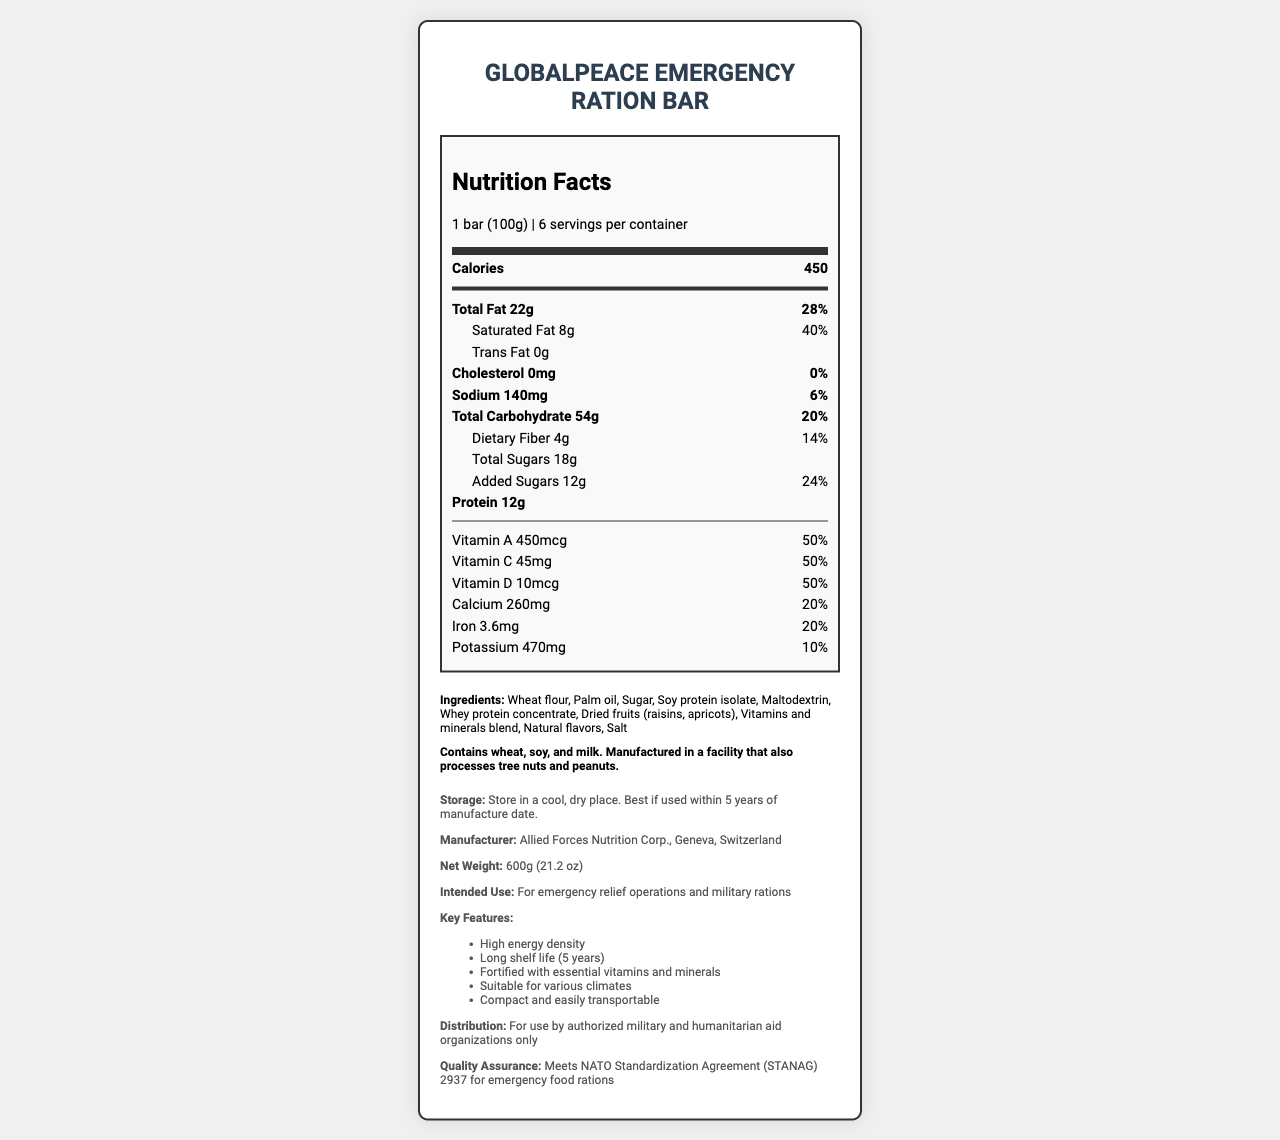who is the manufacturer of the GlobalPeace Emergency Ration Bar? The document explicitly states that the manufacturer is Allied Forces Nutrition Corp., Geneva, Switzerland.
Answer: Allied Forces Nutrition Corp., Geneva, Switzerland what is the serving size of one bar? The document states that the serving size is 1 bar (100g).
Answer: 1 bar (100g) how many calories are in one serving of the emergency ration bar? The document clearly lists the calorie content as 450 per serving.
Answer: 450 calories what are the key ingredients in the GlobalPeace Emergency Ration Bar? The ingredients are listed under the ingredients section of the document.
Answer: Wheat flour, Palm oil, Sugar, Soy protein isolate, Maltodextrin, Whey protein concentrate, Dried fruits (raisins, apricots), Vitamins and minerals blend, Natural flavors, Salt how much saturated fat is in one bar? The document states that there is 8g of saturated fat per bar.
Answer: 8g which of the following vitamins is present in the highest daily value percentage? A. Vitamin A B. Vitamin C C. Vitamin D D. Vitamin K Vitamin A, Vitamin C, and Vitamin D each have a daily value of 50%, but Vitamin K is not listed.
Answer: A. Vitamin A how long is the shelf life of the emergency ration bar? A. 1 year B. 3 years C. 5 years D. 10 years The document mentions that the bar has a long shelf life of 5 years.
Answer: C. 5 years how much protein does one bar contain? The document states that each bar contains 12g of protein.
Answer: 12g true or false: The GlobalPeace Emergency Ration Bar contains peanuts. According to the allergen information, the bar is manufactured in a facility that processes peanuts, but peanuts are not listed as an ingredient in the bar itself.
Answer: False summarize the main features and nutritional content of the GlobalPeace Emergency Ration Bar. The document gives detailed nutrition facts and highlights key features such as high energy density, long shelf life, and suitability for various climates. It also lists the ingredients, allergen information, and storage instructions.
Answer: The GlobalPeace Emergency Ration Bar is designed for emergency relief and military rations. Each 100g bar provides 450 calories, contains 22g of total fat, 8g of saturated fat, 140mg of sodium, 54g of carbohydrates, 4g of fiber, 18g of sugars (including 12g added sugars), and 12g of protein. It is fortified with essential vitamins and minerals such as Vitamin A, Vitamin C, Vitamin D, Calcium, Iron, and Potassium. It has a long shelf life of 5 years and is compact and easily transportable. what is the daily value percentage of calcium in one bar? The document provides that one bar has a daily value of 20% for calcium.
Answer: 20% is this product suitable for individuals with milk allergies? The document lists milk as one of the allergens, so it is not suitable for individuals with milk allergies.
Answer: No what standard does the emergency ration bar meet? The document states that the bar meets the NATO Standardization Agreement (STANAG) 2937 for emergency food rations.
Answer: NATO Standardization Agreement (STANAG) 2937 for emergency food rations what is the primary intended use of the GlobalPeace Emergency Ration Bar? The intended use is specified as for emergency relief operations and military rations.
Answer: For emergency relief operations and military rations when is the best time to use the emergency ration bar? The storage instructions specify that it is best to use the bar within 5 years of the manufacture date.
Answer: Best if used within 5 years of manufacture date what company produces the GlobalPeace Emergency Ration Bar? This question is a repeat of asking the manufacturer, which is Allied Forces Nutrition Corp., Geneva, Switzerland.
Answer: Cannot be determined 